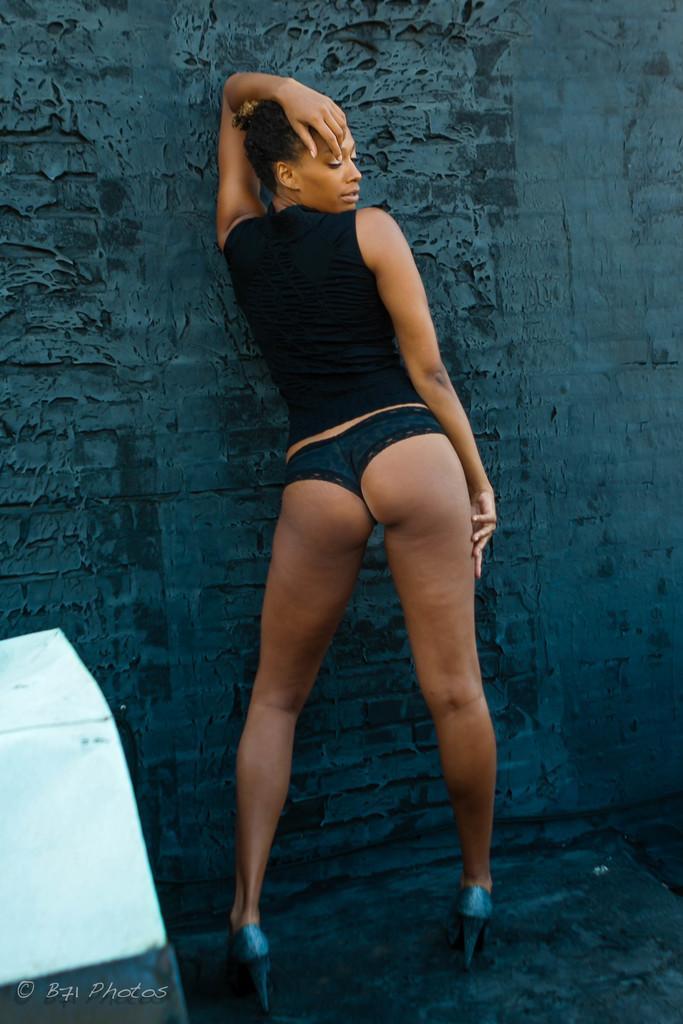Describe this image in one or two sentences. In this image there is a woman standing. She is wearing a black top. Left side there is an object on the floor. Background there is a wall. 